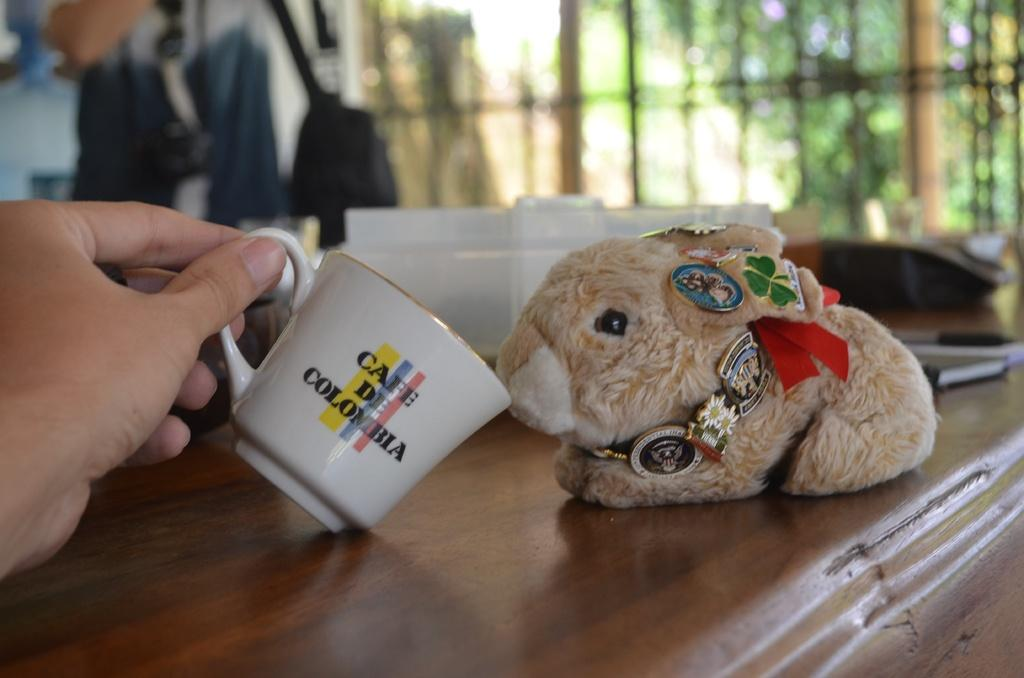What is the person's hand holding in the image? There is a person's hand holding a cup in the image. What else can be seen on the table in the image? There is a doll on a table in the image. Can you describe the background of the image? The background of the image is blurred. Where is the store located in the image? There is no store present in the image. What type of stocking is the person wearing in the image? There is no person visible in the image, only a hand holding a cup and a doll on a table. 